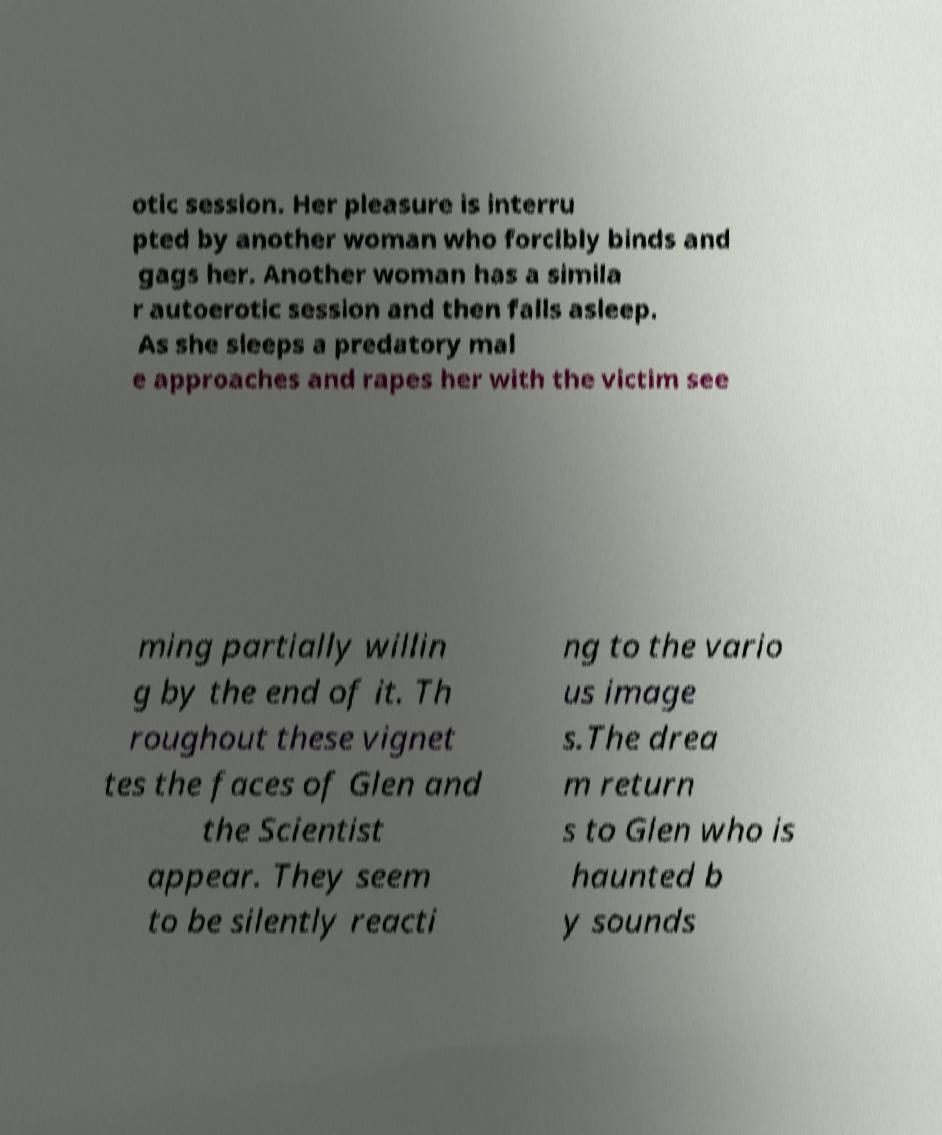Could you assist in decoding the text presented in this image and type it out clearly? otic session. Her pleasure is interru pted by another woman who forcibly binds and gags her. Another woman has a simila r autoerotic session and then falls asleep. As she sleeps a predatory mal e approaches and rapes her with the victim see ming partially willin g by the end of it. Th roughout these vignet tes the faces of Glen and the Scientist appear. They seem to be silently reacti ng to the vario us image s.The drea m return s to Glen who is haunted b y sounds 